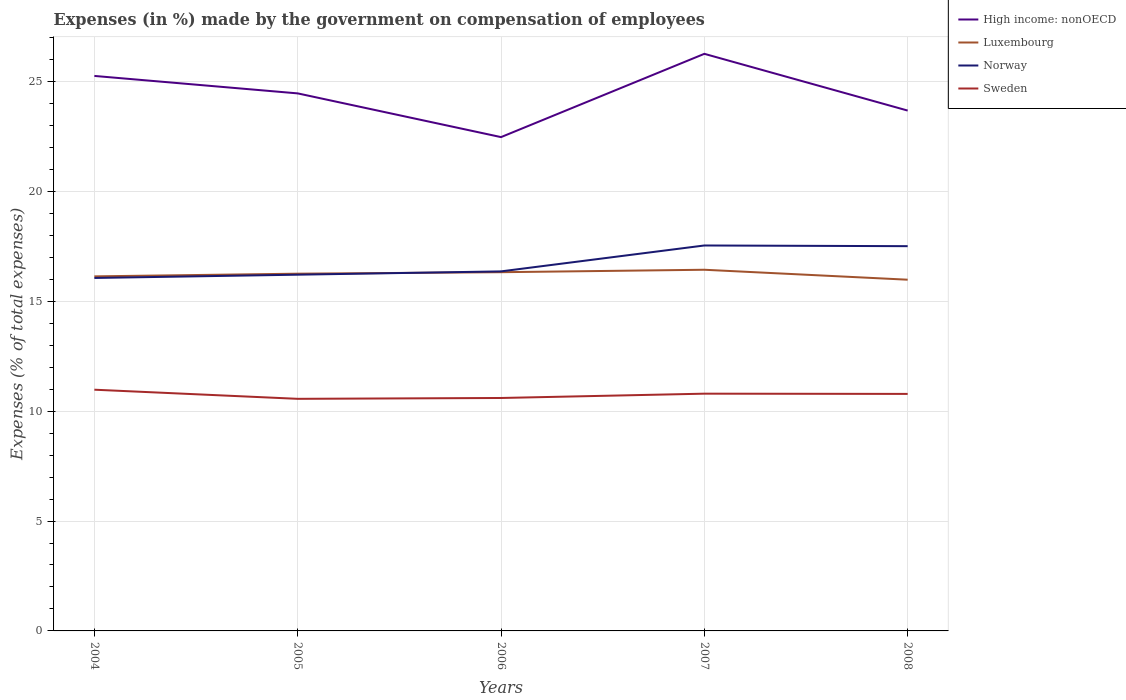How many different coloured lines are there?
Offer a very short reply. 4. Does the line corresponding to High income: nonOECD intersect with the line corresponding to Norway?
Offer a terse response. No. Is the number of lines equal to the number of legend labels?
Ensure brevity in your answer.  Yes. Across all years, what is the maximum percentage of expenses made by the government on compensation of employees in Norway?
Your answer should be very brief. 16.06. What is the total percentage of expenses made by the government on compensation of employees in Sweden in the graph?
Your answer should be compact. 0.18. What is the difference between the highest and the second highest percentage of expenses made by the government on compensation of employees in Sweden?
Your answer should be very brief. 0.42. What is the difference between the highest and the lowest percentage of expenses made by the government on compensation of employees in Norway?
Keep it short and to the point. 2. Is the percentage of expenses made by the government on compensation of employees in Luxembourg strictly greater than the percentage of expenses made by the government on compensation of employees in High income: nonOECD over the years?
Your answer should be very brief. Yes. How many years are there in the graph?
Your response must be concise. 5. What is the difference between two consecutive major ticks on the Y-axis?
Provide a succinct answer. 5. Where does the legend appear in the graph?
Keep it short and to the point. Top right. What is the title of the graph?
Ensure brevity in your answer.  Expenses (in %) made by the government on compensation of employees. Does "Tajikistan" appear as one of the legend labels in the graph?
Make the answer very short. No. What is the label or title of the X-axis?
Your answer should be very brief. Years. What is the label or title of the Y-axis?
Your response must be concise. Expenses (% of total expenses). What is the Expenses (% of total expenses) in High income: nonOECD in 2004?
Your answer should be very brief. 25.25. What is the Expenses (% of total expenses) in Luxembourg in 2004?
Keep it short and to the point. 16.13. What is the Expenses (% of total expenses) in Norway in 2004?
Provide a succinct answer. 16.06. What is the Expenses (% of total expenses) in Sweden in 2004?
Offer a terse response. 10.97. What is the Expenses (% of total expenses) in High income: nonOECD in 2005?
Offer a very short reply. 24.46. What is the Expenses (% of total expenses) in Luxembourg in 2005?
Your answer should be compact. 16.25. What is the Expenses (% of total expenses) in Norway in 2005?
Provide a succinct answer. 16.21. What is the Expenses (% of total expenses) in Sweden in 2005?
Offer a very short reply. 10.56. What is the Expenses (% of total expenses) of High income: nonOECD in 2006?
Your answer should be very brief. 22.47. What is the Expenses (% of total expenses) in Luxembourg in 2006?
Give a very brief answer. 16.32. What is the Expenses (% of total expenses) of Norway in 2006?
Ensure brevity in your answer.  16.36. What is the Expenses (% of total expenses) of Sweden in 2006?
Your response must be concise. 10.6. What is the Expenses (% of total expenses) of High income: nonOECD in 2007?
Make the answer very short. 26.26. What is the Expenses (% of total expenses) in Luxembourg in 2007?
Ensure brevity in your answer.  16.43. What is the Expenses (% of total expenses) of Norway in 2007?
Your response must be concise. 17.54. What is the Expenses (% of total expenses) in Sweden in 2007?
Ensure brevity in your answer.  10.79. What is the Expenses (% of total expenses) in High income: nonOECD in 2008?
Provide a succinct answer. 23.67. What is the Expenses (% of total expenses) of Luxembourg in 2008?
Your response must be concise. 15.98. What is the Expenses (% of total expenses) in Norway in 2008?
Make the answer very short. 17.51. What is the Expenses (% of total expenses) of Sweden in 2008?
Offer a terse response. 10.78. Across all years, what is the maximum Expenses (% of total expenses) of High income: nonOECD?
Offer a terse response. 26.26. Across all years, what is the maximum Expenses (% of total expenses) in Luxembourg?
Your answer should be compact. 16.43. Across all years, what is the maximum Expenses (% of total expenses) in Norway?
Your response must be concise. 17.54. Across all years, what is the maximum Expenses (% of total expenses) in Sweden?
Your answer should be very brief. 10.97. Across all years, what is the minimum Expenses (% of total expenses) in High income: nonOECD?
Ensure brevity in your answer.  22.47. Across all years, what is the minimum Expenses (% of total expenses) in Luxembourg?
Ensure brevity in your answer.  15.98. Across all years, what is the minimum Expenses (% of total expenses) of Norway?
Give a very brief answer. 16.06. Across all years, what is the minimum Expenses (% of total expenses) of Sweden?
Ensure brevity in your answer.  10.56. What is the total Expenses (% of total expenses) in High income: nonOECD in the graph?
Offer a terse response. 122.1. What is the total Expenses (% of total expenses) in Luxembourg in the graph?
Make the answer very short. 81.12. What is the total Expenses (% of total expenses) of Norway in the graph?
Keep it short and to the point. 83.67. What is the total Expenses (% of total expenses) of Sweden in the graph?
Keep it short and to the point. 53.71. What is the difference between the Expenses (% of total expenses) of High income: nonOECD in 2004 and that in 2005?
Make the answer very short. 0.79. What is the difference between the Expenses (% of total expenses) in Luxembourg in 2004 and that in 2005?
Ensure brevity in your answer.  -0.12. What is the difference between the Expenses (% of total expenses) in Norway in 2004 and that in 2005?
Your answer should be compact. -0.15. What is the difference between the Expenses (% of total expenses) in Sweden in 2004 and that in 2005?
Your answer should be very brief. 0.42. What is the difference between the Expenses (% of total expenses) in High income: nonOECD in 2004 and that in 2006?
Provide a succinct answer. 2.78. What is the difference between the Expenses (% of total expenses) of Luxembourg in 2004 and that in 2006?
Ensure brevity in your answer.  -0.19. What is the difference between the Expenses (% of total expenses) of Norway in 2004 and that in 2006?
Make the answer very short. -0.3. What is the difference between the Expenses (% of total expenses) in Sweden in 2004 and that in 2006?
Offer a terse response. 0.38. What is the difference between the Expenses (% of total expenses) of High income: nonOECD in 2004 and that in 2007?
Offer a very short reply. -1.01. What is the difference between the Expenses (% of total expenses) in Luxembourg in 2004 and that in 2007?
Offer a terse response. -0.3. What is the difference between the Expenses (% of total expenses) in Norway in 2004 and that in 2007?
Your response must be concise. -1.48. What is the difference between the Expenses (% of total expenses) in Sweden in 2004 and that in 2007?
Give a very brief answer. 0.18. What is the difference between the Expenses (% of total expenses) in High income: nonOECD in 2004 and that in 2008?
Offer a terse response. 1.58. What is the difference between the Expenses (% of total expenses) of Luxembourg in 2004 and that in 2008?
Your answer should be compact. 0.15. What is the difference between the Expenses (% of total expenses) in Norway in 2004 and that in 2008?
Provide a short and direct response. -1.45. What is the difference between the Expenses (% of total expenses) in Sweden in 2004 and that in 2008?
Ensure brevity in your answer.  0.19. What is the difference between the Expenses (% of total expenses) in High income: nonOECD in 2005 and that in 2006?
Your answer should be compact. 1.99. What is the difference between the Expenses (% of total expenses) of Luxembourg in 2005 and that in 2006?
Your response must be concise. -0.07. What is the difference between the Expenses (% of total expenses) in Norway in 2005 and that in 2006?
Your answer should be very brief. -0.15. What is the difference between the Expenses (% of total expenses) of Sweden in 2005 and that in 2006?
Your answer should be compact. -0.04. What is the difference between the Expenses (% of total expenses) in Luxembourg in 2005 and that in 2007?
Provide a succinct answer. -0.18. What is the difference between the Expenses (% of total expenses) in Norway in 2005 and that in 2007?
Provide a succinct answer. -1.33. What is the difference between the Expenses (% of total expenses) in Sweden in 2005 and that in 2007?
Offer a terse response. -0.23. What is the difference between the Expenses (% of total expenses) of High income: nonOECD in 2005 and that in 2008?
Ensure brevity in your answer.  0.78. What is the difference between the Expenses (% of total expenses) of Luxembourg in 2005 and that in 2008?
Give a very brief answer. 0.27. What is the difference between the Expenses (% of total expenses) of Norway in 2005 and that in 2008?
Give a very brief answer. -1.3. What is the difference between the Expenses (% of total expenses) in Sweden in 2005 and that in 2008?
Provide a short and direct response. -0.22. What is the difference between the Expenses (% of total expenses) of High income: nonOECD in 2006 and that in 2007?
Provide a succinct answer. -3.79. What is the difference between the Expenses (% of total expenses) of Luxembourg in 2006 and that in 2007?
Ensure brevity in your answer.  -0.11. What is the difference between the Expenses (% of total expenses) in Norway in 2006 and that in 2007?
Offer a terse response. -1.18. What is the difference between the Expenses (% of total expenses) of Sweden in 2006 and that in 2007?
Make the answer very short. -0.2. What is the difference between the Expenses (% of total expenses) in High income: nonOECD in 2006 and that in 2008?
Ensure brevity in your answer.  -1.21. What is the difference between the Expenses (% of total expenses) of Luxembourg in 2006 and that in 2008?
Keep it short and to the point. 0.34. What is the difference between the Expenses (% of total expenses) in Norway in 2006 and that in 2008?
Your answer should be compact. -1.15. What is the difference between the Expenses (% of total expenses) of Sweden in 2006 and that in 2008?
Make the answer very short. -0.19. What is the difference between the Expenses (% of total expenses) in High income: nonOECD in 2007 and that in 2008?
Offer a very short reply. 2.58. What is the difference between the Expenses (% of total expenses) of Luxembourg in 2007 and that in 2008?
Keep it short and to the point. 0.45. What is the difference between the Expenses (% of total expenses) in Norway in 2007 and that in 2008?
Offer a very short reply. 0.03. What is the difference between the Expenses (% of total expenses) of Sweden in 2007 and that in 2008?
Offer a very short reply. 0.01. What is the difference between the Expenses (% of total expenses) in High income: nonOECD in 2004 and the Expenses (% of total expenses) in Luxembourg in 2005?
Make the answer very short. 9. What is the difference between the Expenses (% of total expenses) of High income: nonOECD in 2004 and the Expenses (% of total expenses) of Norway in 2005?
Offer a very short reply. 9.04. What is the difference between the Expenses (% of total expenses) in High income: nonOECD in 2004 and the Expenses (% of total expenses) in Sweden in 2005?
Give a very brief answer. 14.69. What is the difference between the Expenses (% of total expenses) in Luxembourg in 2004 and the Expenses (% of total expenses) in Norway in 2005?
Make the answer very short. -0.08. What is the difference between the Expenses (% of total expenses) of Luxembourg in 2004 and the Expenses (% of total expenses) of Sweden in 2005?
Offer a terse response. 5.57. What is the difference between the Expenses (% of total expenses) of Norway in 2004 and the Expenses (% of total expenses) of Sweden in 2005?
Your answer should be very brief. 5.5. What is the difference between the Expenses (% of total expenses) in High income: nonOECD in 2004 and the Expenses (% of total expenses) in Luxembourg in 2006?
Your response must be concise. 8.93. What is the difference between the Expenses (% of total expenses) in High income: nonOECD in 2004 and the Expenses (% of total expenses) in Norway in 2006?
Ensure brevity in your answer.  8.89. What is the difference between the Expenses (% of total expenses) of High income: nonOECD in 2004 and the Expenses (% of total expenses) of Sweden in 2006?
Provide a short and direct response. 14.65. What is the difference between the Expenses (% of total expenses) of Luxembourg in 2004 and the Expenses (% of total expenses) of Norway in 2006?
Offer a terse response. -0.23. What is the difference between the Expenses (% of total expenses) in Luxembourg in 2004 and the Expenses (% of total expenses) in Sweden in 2006?
Ensure brevity in your answer.  5.53. What is the difference between the Expenses (% of total expenses) of Norway in 2004 and the Expenses (% of total expenses) of Sweden in 2006?
Your answer should be compact. 5.46. What is the difference between the Expenses (% of total expenses) in High income: nonOECD in 2004 and the Expenses (% of total expenses) in Luxembourg in 2007?
Your response must be concise. 8.82. What is the difference between the Expenses (% of total expenses) of High income: nonOECD in 2004 and the Expenses (% of total expenses) of Norway in 2007?
Make the answer very short. 7.71. What is the difference between the Expenses (% of total expenses) of High income: nonOECD in 2004 and the Expenses (% of total expenses) of Sweden in 2007?
Provide a succinct answer. 14.46. What is the difference between the Expenses (% of total expenses) in Luxembourg in 2004 and the Expenses (% of total expenses) in Norway in 2007?
Your answer should be compact. -1.4. What is the difference between the Expenses (% of total expenses) in Luxembourg in 2004 and the Expenses (% of total expenses) in Sweden in 2007?
Your response must be concise. 5.34. What is the difference between the Expenses (% of total expenses) in Norway in 2004 and the Expenses (% of total expenses) in Sweden in 2007?
Provide a short and direct response. 5.26. What is the difference between the Expenses (% of total expenses) of High income: nonOECD in 2004 and the Expenses (% of total expenses) of Luxembourg in 2008?
Your answer should be very brief. 9.27. What is the difference between the Expenses (% of total expenses) of High income: nonOECD in 2004 and the Expenses (% of total expenses) of Norway in 2008?
Give a very brief answer. 7.75. What is the difference between the Expenses (% of total expenses) of High income: nonOECD in 2004 and the Expenses (% of total expenses) of Sweden in 2008?
Give a very brief answer. 14.47. What is the difference between the Expenses (% of total expenses) in Luxembourg in 2004 and the Expenses (% of total expenses) in Norway in 2008?
Your response must be concise. -1.37. What is the difference between the Expenses (% of total expenses) in Luxembourg in 2004 and the Expenses (% of total expenses) in Sweden in 2008?
Ensure brevity in your answer.  5.35. What is the difference between the Expenses (% of total expenses) in Norway in 2004 and the Expenses (% of total expenses) in Sweden in 2008?
Make the answer very short. 5.27. What is the difference between the Expenses (% of total expenses) of High income: nonOECD in 2005 and the Expenses (% of total expenses) of Luxembourg in 2006?
Keep it short and to the point. 8.14. What is the difference between the Expenses (% of total expenses) in High income: nonOECD in 2005 and the Expenses (% of total expenses) in Norway in 2006?
Your answer should be very brief. 8.1. What is the difference between the Expenses (% of total expenses) of High income: nonOECD in 2005 and the Expenses (% of total expenses) of Sweden in 2006?
Make the answer very short. 13.86. What is the difference between the Expenses (% of total expenses) of Luxembourg in 2005 and the Expenses (% of total expenses) of Norway in 2006?
Give a very brief answer. -0.1. What is the difference between the Expenses (% of total expenses) in Luxembourg in 2005 and the Expenses (% of total expenses) in Sweden in 2006?
Your answer should be compact. 5.66. What is the difference between the Expenses (% of total expenses) of Norway in 2005 and the Expenses (% of total expenses) of Sweden in 2006?
Keep it short and to the point. 5.61. What is the difference between the Expenses (% of total expenses) in High income: nonOECD in 2005 and the Expenses (% of total expenses) in Luxembourg in 2007?
Your response must be concise. 8.02. What is the difference between the Expenses (% of total expenses) of High income: nonOECD in 2005 and the Expenses (% of total expenses) of Norway in 2007?
Keep it short and to the point. 6.92. What is the difference between the Expenses (% of total expenses) of High income: nonOECD in 2005 and the Expenses (% of total expenses) of Sweden in 2007?
Give a very brief answer. 13.66. What is the difference between the Expenses (% of total expenses) in Luxembourg in 2005 and the Expenses (% of total expenses) in Norway in 2007?
Your answer should be very brief. -1.28. What is the difference between the Expenses (% of total expenses) of Luxembourg in 2005 and the Expenses (% of total expenses) of Sweden in 2007?
Your answer should be compact. 5.46. What is the difference between the Expenses (% of total expenses) in Norway in 2005 and the Expenses (% of total expenses) in Sweden in 2007?
Keep it short and to the point. 5.41. What is the difference between the Expenses (% of total expenses) of High income: nonOECD in 2005 and the Expenses (% of total expenses) of Luxembourg in 2008?
Provide a succinct answer. 8.48. What is the difference between the Expenses (% of total expenses) of High income: nonOECD in 2005 and the Expenses (% of total expenses) of Norway in 2008?
Give a very brief answer. 6.95. What is the difference between the Expenses (% of total expenses) in High income: nonOECD in 2005 and the Expenses (% of total expenses) in Sweden in 2008?
Your response must be concise. 13.67. What is the difference between the Expenses (% of total expenses) in Luxembourg in 2005 and the Expenses (% of total expenses) in Norway in 2008?
Offer a very short reply. -1.25. What is the difference between the Expenses (% of total expenses) in Luxembourg in 2005 and the Expenses (% of total expenses) in Sweden in 2008?
Offer a very short reply. 5.47. What is the difference between the Expenses (% of total expenses) in Norway in 2005 and the Expenses (% of total expenses) in Sweden in 2008?
Offer a terse response. 5.42. What is the difference between the Expenses (% of total expenses) of High income: nonOECD in 2006 and the Expenses (% of total expenses) of Luxembourg in 2007?
Your response must be concise. 6.04. What is the difference between the Expenses (% of total expenses) in High income: nonOECD in 2006 and the Expenses (% of total expenses) in Norway in 2007?
Provide a succinct answer. 4.93. What is the difference between the Expenses (% of total expenses) of High income: nonOECD in 2006 and the Expenses (% of total expenses) of Sweden in 2007?
Keep it short and to the point. 11.67. What is the difference between the Expenses (% of total expenses) of Luxembourg in 2006 and the Expenses (% of total expenses) of Norway in 2007?
Offer a terse response. -1.22. What is the difference between the Expenses (% of total expenses) in Luxembourg in 2006 and the Expenses (% of total expenses) in Sweden in 2007?
Make the answer very short. 5.53. What is the difference between the Expenses (% of total expenses) of Norway in 2006 and the Expenses (% of total expenses) of Sweden in 2007?
Provide a short and direct response. 5.56. What is the difference between the Expenses (% of total expenses) of High income: nonOECD in 2006 and the Expenses (% of total expenses) of Luxembourg in 2008?
Offer a very short reply. 6.49. What is the difference between the Expenses (% of total expenses) in High income: nonOECD in 2006 and the Expenses (% of total expenses) in Norway in 2008?
Offer a terse response. 4.96. What is the difference between the Expenses (% of total expenses) of High income: nonOECD in 2006 and the Expenses (% of total expenses) of Sweden in 2008?
Give a very brief answer. 11.68. What is the difference between the Expenses (% of total expenses) of Luxembourg in 2006 and the Expenses (% of total expenses) of Norway in 2008?
Give a very brief answer. -1.18. What is the difference between the Expenses (% of total expenses) in Luxembourg in 2006 and the Expenses (% of total expenses) in Sweden in 2008?
Your answer should be very brief. 5.54. What is the difference between the Expenses (% of total expenses) of Norway in 2006 and the Expenses (% of total expenses) of Sweden in 2008?
Keep it short and to the point. 5.57. What is the difference between the Expenses (% of total expenses) in High income: nonOECD in 2007 and the Expenses (% of total expenses) in Luxembourg in 2008?
Keep it short and to the point. 10.28. What is the difference between the Expenses (% of total expenses) in High income: nonOECD in 2007 and the Expenses (% of total expenses) in Norway in 2008?
Make the answer very short. 8.75. What is the difference between the Expenses (% of total expenses) in High income: nonOECD in 2007 and the Expenses (% of total expenses) in Sweden in 2008?
Your answer should be very brief. 15.47. What is the difference between the Expenses (% of total expenses) in Luxembourg in 2007 and the Expenses (% of total expenses) in Norway in 2008?
Your response must be concise. -1.07. What is the difference between the Expenses (% of total expenses) in Luxembourg in 2007 and the Expenses (% of total expenses) in Sweden in 2008?
Your answer should be compact. 5.65. What is the difference between the Expenses (% of total expenses) of Norway in 2007 and the Expenses (% of total expenses) of Sweden in 2008?
Ensure brevity in your answer.  6.75. What is the average Expenses (% of total expenses) in High income: nonOECD per year?
Make the answer very short. 24.42. What is the average Expenses (% of total expenses) in Luxembourg per year?
Offer a terse response. 16.22. What is the average Expenses (% of total expenses) in Norway per year?
Your answer should be compact. 16.73. What is the average Expenses (% of total expenses) in Sweden per year?
Offer a very short reply. 10.74. In the year 2004, what is the difference between the Expenses (% of total expenses) of High income: nonOECD and Expenses (% of total expenses) of Luxembourg?
Keep it short and to the point. 9.12. In the year 2004, what is the difference between the Expenses (% of total expenses) of High income: nonOECD and Expenses (% of total expenses) of Norway?
Make the answer very short. 9.19. In the year 2004, what is the difference between the Expenses (% of total expenses) in High income: nonOECD and Expenses (% of total expenses) in Sweden?
Your response must be concise. 14.28. In the year 2004, what is the difference between the Expenses (% of total expenses) in Luxembourg and Expenses (% of total expenses) in Norway?
Offer a terse response. 0.07. In the year 2004, what is the difference between the Expenses (% of total expenses) of Luxembourg and Expenses (% of total expenses) of Sweden?
Give a very brief answer. 5.16. In the year 2004, what is the difference between the Expenses (% of total expenses) in Norway and Expenses (% of total expenses) in Sweden?
Make the answer very short. 5.08. In the year 2005, what is the difference between the Expenses (% of total expenses) in High income: nonOECD and Expenses (% of total expenses) in Luxembourg?
Your response must be concise. 8.2. In the year 2005, what is the difference between the Expenses (% of total expenses) of High income: nonOECD and Expenses (% of total expenses) of Norway?
Offer a very short reply. 8.25. In the year 2005, what is the difference between the Expenses (% of total expenses) of High income: nonOECD and Expenses (% of total expenses) of Sweden?
Make the answer very short. 13.9. In the year 2005, what is the difference between the Expenses (% of total expenses) of Luxembourg and Expenses (% of total expenses) of Norway?
Keep it short and to the point. 0.05. In the year 2005, what is the difference between the Expenses (% of total expenses) of Luxembourg and Expenses (% of total expenses) of Sweden?
Give a very brief answer. 5.69. In the year 2005, what is the difference between the Expenses (% of total expenses) of Norway and Expenses (% of total expenses) of Sweden?
Your response must be concise. 5.65. In the year 2006, what is the difference between the Expenses (% of total expenses) in High income: nonOECD and Expenses (% of total expenses) in Luxembourg?
Your response must be concise. 6.15. In the year 2006, what is the difference between the Expenses (% of total expenses) of High income: nonOECD and Expenses (% of total expenses) of Norway?
Your answer should be compact. 6.11. In the year 2006, what is the difference between the Expenses (% of total expenses) of High income: nonOECD and Expenses (% of total expenses) of Sweden?
Make the answer very short. 11.87. In the year 2006, what is the difference between the Expenses (% of total expenses) of Luxembourg and Expenses (% of total expenses) of Norway?
Your answer should be very brief. -0.04. In the year 2006, what is the difference between the Expenses (% of total expenses) in Luxembourg and Expenses (% of total expenses) in Sweden?
Your answer should be compact. 5.72. In the year 2006, what is the difference between the Expenses (% of total expenses) in Norway and Expenses (% of total expenses) in Sweden?
Provide a short and direct response. 5.76. In the year 2007, what is the difference between the Expenses (% of total expenses) of High income: nonOECD and Expenses (% of total expenses) of Luxembourg?
Offer a very short reply. 9.82. In the year 2007, what is the difference between the Expenses (% of total expenses) of High income: nonOECD and Expenses (% of total expenses) of Norway?
Provide a short and direct response. 8.72. In the year 2007, what is the difference between the Expenses (% of total expenses) of High income: nonOECD and Expenses (% of total expenses) of Sweden?
Provide a short and direct response. 15.46. In the year 2007, what is the difference between the Expenses (% of total expenses) in Luxembourg and Expenses (% of total expenses) in Norway?
Your answer should be compact. -1.1. In the year 2007, what is the difference between the Expenses (% of total expenses) of Luxembourg and Expenses (% of total expenses) of Sweden?
Ensure brevity in your answer.  5.64. In the year 2007, what is the difference between the Expenses (% of total expenses) in Norway and Expenses (% of total expenses) in Sweden?
Ensure brevity in your answer.  6.74. In the year 2008, what is the difference between the Expenses (% of total expenses) of High income: nonOECD and Expenses (% of total expenses) of Luxembourg?
Provide a short and direct response. 7.7. In the year 2008, what is the difference between the Expenses (% of total expenses) of High income: nonOECD and Expenses (% of total expenses) of Norway?
Ensure brevity in your answer.  6.17. In the year 2008, what is the difference between the Expenses (% of total expenses) in High income: nonOECD and Expenses (% of total expenses) in Sweden?
Keep it short and to the point. 12.89. In the year 2008, what is the difference between the Expenses (% of total expenses) of Luxembourg and Expenses (% of total expenses) of Norway?
Ensure brevity in your answer.  -1.53. In the year 2008, what is the difference between the Expenses (% of total expenses) of Luxembourg and Expenses (% of total expenses) of Sweden?
Offer a terse response. 5.2. In the year 2008, what is the difference between the Expenses (% of total expenses) in Norway and Expenses (% of total expenses) in Sweden?
Give a very brief answer. 6.72. What is the ratio of the Expenses (% of total expenses) of High income: nonOECD in 2004 to that in 2005?
Provide a short and direct response. 1.03. What is the ratio of the Expenses (% of total expenses) in Sweden in 2004 to that in 2005?
Your response must be concise. 1.04. What is the ratio of the Expenses (% of total expenses) of High income: nonOECD in 2004 to that in 2006?
Your answer should be very brief. 1.12. What is the ratio of the Expenses (% of total expenses) in Luxembourg in 2004 to that in 2006?
Make the answer very short. 0.99. What is the ratio of the Expenses (% of total expenses) of Norway in 2004 to that in 2006?
Offer a very short reply. 0.98. What is the ratio of the Expenses (% of total expenses) of Sweden in 2004 to that in 2006?
Provide a short and direct response. 1.04. What is the ratio of the Expenses (% of total expenses) in High income: nonOECD in 2004 to that in 2007?
Provide a short and direct response. 0.96. What is the ratio of the Expenses (% of total expenses) in Luxembourg in 2004 to that in 2007?
Offer a terse response. 0.98. What is the ratio of the Expenses (% of total expenses) in Norway in 2004 to that in 2007?
Make the answer very short. 0.92. What is the ratio of the Expenses (% of total expenses) in Sweden in 2004 to that in 2007?
Give a very brief answer. 1.02. What is the ratio of the Expenses (% of total expenses) of High income: nonOECD in 2004 to that in 2008?
Provide a short and direct response. 1.07. What is the ratio of the Expenses (% of total expenses) of Luxembourg in 2004 to that in 2008?
Keep it short and to the point. 1.01. What is the ratio of the Expenses (% of total expenses) of Norway in 2004 to that in 2008?
Make the answer very short. 0.92. What is the ratio of the Expenses (% of total expenses) in Sweden in 2004 to that in 2008?
Ensure brevity in your answer.  1.02. What is the ratio of the Expenses (% of total expenses) of High income: nonOECD in 2005 to that in 2006?
Your answer should be very brief. 1.09. What is the ratio of the Expenses (% of total expenses) in Norway in 2005 to that in 2006?
Give a very brief answer. 0.99. What is the ratio of the Expenses (% of total expenses) in Sweden in 2005 to that in 2006?
Make the answer very short. 1. What is the ratio of the Expenses (% of total expenses) of High income: nonOECD in 2005 to that in 2007?
Keep it short and to the point. 0.93. What is the ratio of the Expenses (% of total expenses) of Norway in 2005 to that in 2007?
Give a very brief answer. 0.92. What is the ratio of the Expenses (% of total expenses) in Sweden in 2005 to that in 2007?
Provide a succinct answer. 0.98. What is the ratio of the Expenses (% of total expenses) of High income: nonOECD in 2005 to that in 2008?
Ensure brevity in your answer.  1.03. What is the ratio of the Expenses (% of total expenses) of Luxembourg in 2005 to that in 2008?
Offer a very short reply. 1.02. What is the ratio of the Expenses (% of total expenses) of Norway in 2005 to that in 2008?
Make the answer very short. 0.93. What is the ratio of the Expenses (% of total expenses) of Sweden in 2005 to that in 2008?
Provide a succinct answer. 0.98. What is the ratio of the Expenses (% of total expenses) in High income: nonOECD in 2006 to that in 2007?
Make the answer very short. 0.86. What is the ratio of the Expenses (% of total expenses) of Norway in 2006 to that in 2007?
Ensure brevity in your answer.  0.93. What is the ratio of the Expenses (% of total expenses) of Sweden in 2006 to that in 2007?
Provide a short and direct response. 0.98. What is the ratio of the Expenses (% of total expenses) of High income: nonOECD in 2006 to that in 2008?
Provide a succinct answer. 0.95. What is the ratio of the Expenses (% of total expenses) in Luxembourg in 2006 to that in 2008?
Provide a short and direct response. 1.02. What is the ratio of the Expenses (% of total expenses) of Norway in 2006 to that in 2008?
Keep it short and to the point. 0.93. What is the ratio of the Expenses (% of total expenses) of Sweden in 2006 to that in 2008?
Your answer should be compact. 0.98. What is the ratio of the Expenses (% of total expenses) in High income: nonOECD in 2007 to that in 2008?
Give a very brief answer. 1.11. What is the ratio of the Expenses (% of total expenses) of Luxembourg in 2007 to that in 2008?
Your response must be concise. 1.03. What is the ratio of the Expenses (% of total expenses) in Sweden in 2007 to that in 2008?
Provide a short and direct response. 1. What is the difference between the highest and the second highest Expenses (% of total expenses) of High income: nonOECD?
Ensure brevity in your answer.  1.01. What is the difference between the highest and the second highest Expenses (% of total expenses) in Luxembourg?
Make the answer very short. 0.11. What is the difference between the highest and the second highest Expenses (% of total expenses) of Norway?
Give a very brief answer. 0.03. What is the difference between the highest and the second highest Expenses (% of total expenses) of Sweden?
Ensure brevity in your answer.  0.18. What is the difference between the highest and the lowest Expenses (% of total expenses) of High income: nonOECD?
Make the answer very short. 3.79. What is the difference between the highest and the lowest Expenses (% of total expenses) in Luxembourg?
Ensure brevity in your answer.  0.45. What is the difference between the highest and the lowest Expenses (% of total expenses) of Norway?
Offer a terse response. 1.48. What is the difference between the highest and the lowest Expenses (% of total expenses) in Sweden?
Make the answer very short. 0.42. 